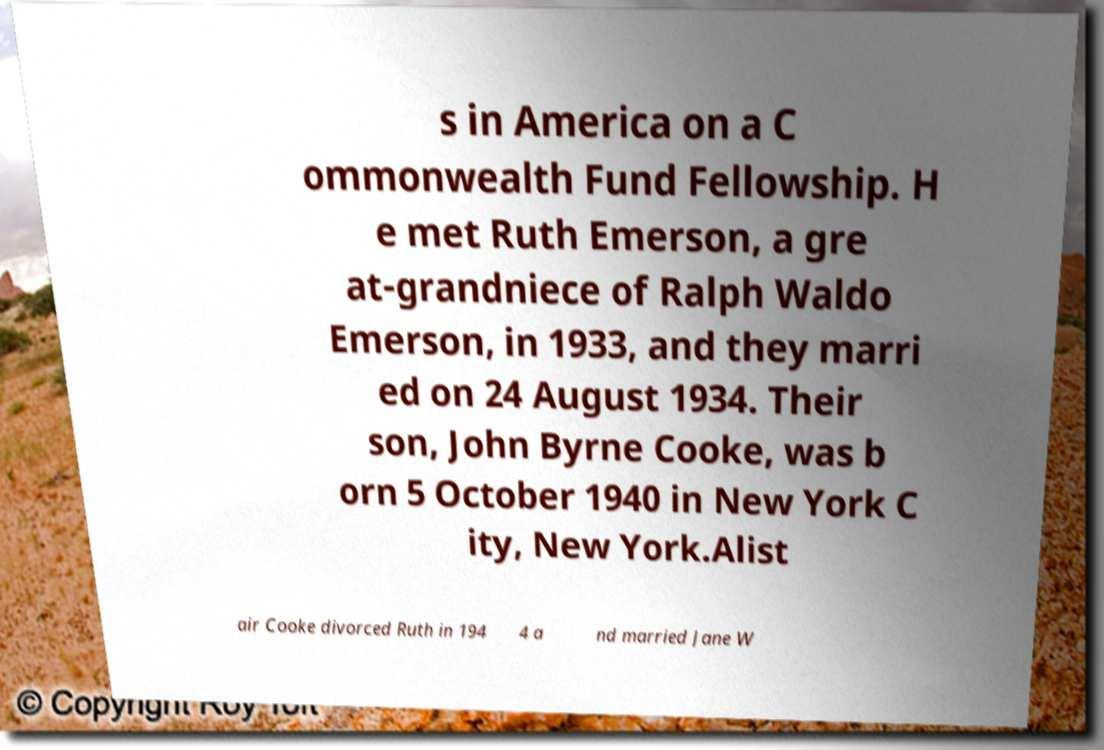Can you accurately transcribe the text from the provided image for me? s in America on a C ommonwealth Fund Fellowship. H e met Ruth Emerson, a gre at-grandniece of Ralph Waldo Emerson, in 1933, and they marri ed on 24 August 1934. Their son, John Byrne Cooke, was b orn 5 October 1940 in New York C ity, New York.Alist air Cooke divorced Ruth in 194 4 a nd married Jane W 